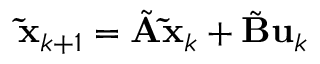<formula> <loc_0><loc_0><loc_500><loc_500>\tilde { x } _ { k + 1 } = \tilde { A } \tilde { x } _ { k } + \tilde { B } u _ { k }</formula> 